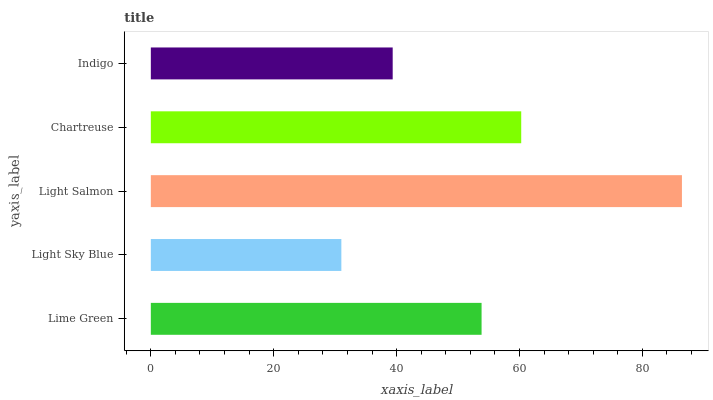Is Light Sky Blue the minimum?
Answer yes or no. Yes. Is Light Salmon the maximum?
Answer yes or no. Yes. Is Light Salmon the minimum?
Answer yes or no. No. Is Light Sky Blue the maximum?
Answer yes or no. No. Is Light Salmon greater than Light Sky Blue?
Answer yes or no. Yes. Is Light Sky Blue less than Light Salmon?
Answer yes or no. Yes. Is Light Sky Blue greater than Light Salmon?
Answer yes or no. No. Is Light Salmon less than Light Sky Blue?
Answer yes or no. No. Is Lime Green the high median?
Answer yes or no. Yes. Is Lime Green the low median?
Answer yes or no. Yes. Is Light Salmon the high median?
Answer yes or no. No. Is Light Salmon the low median?
Answer yes or no. No. 